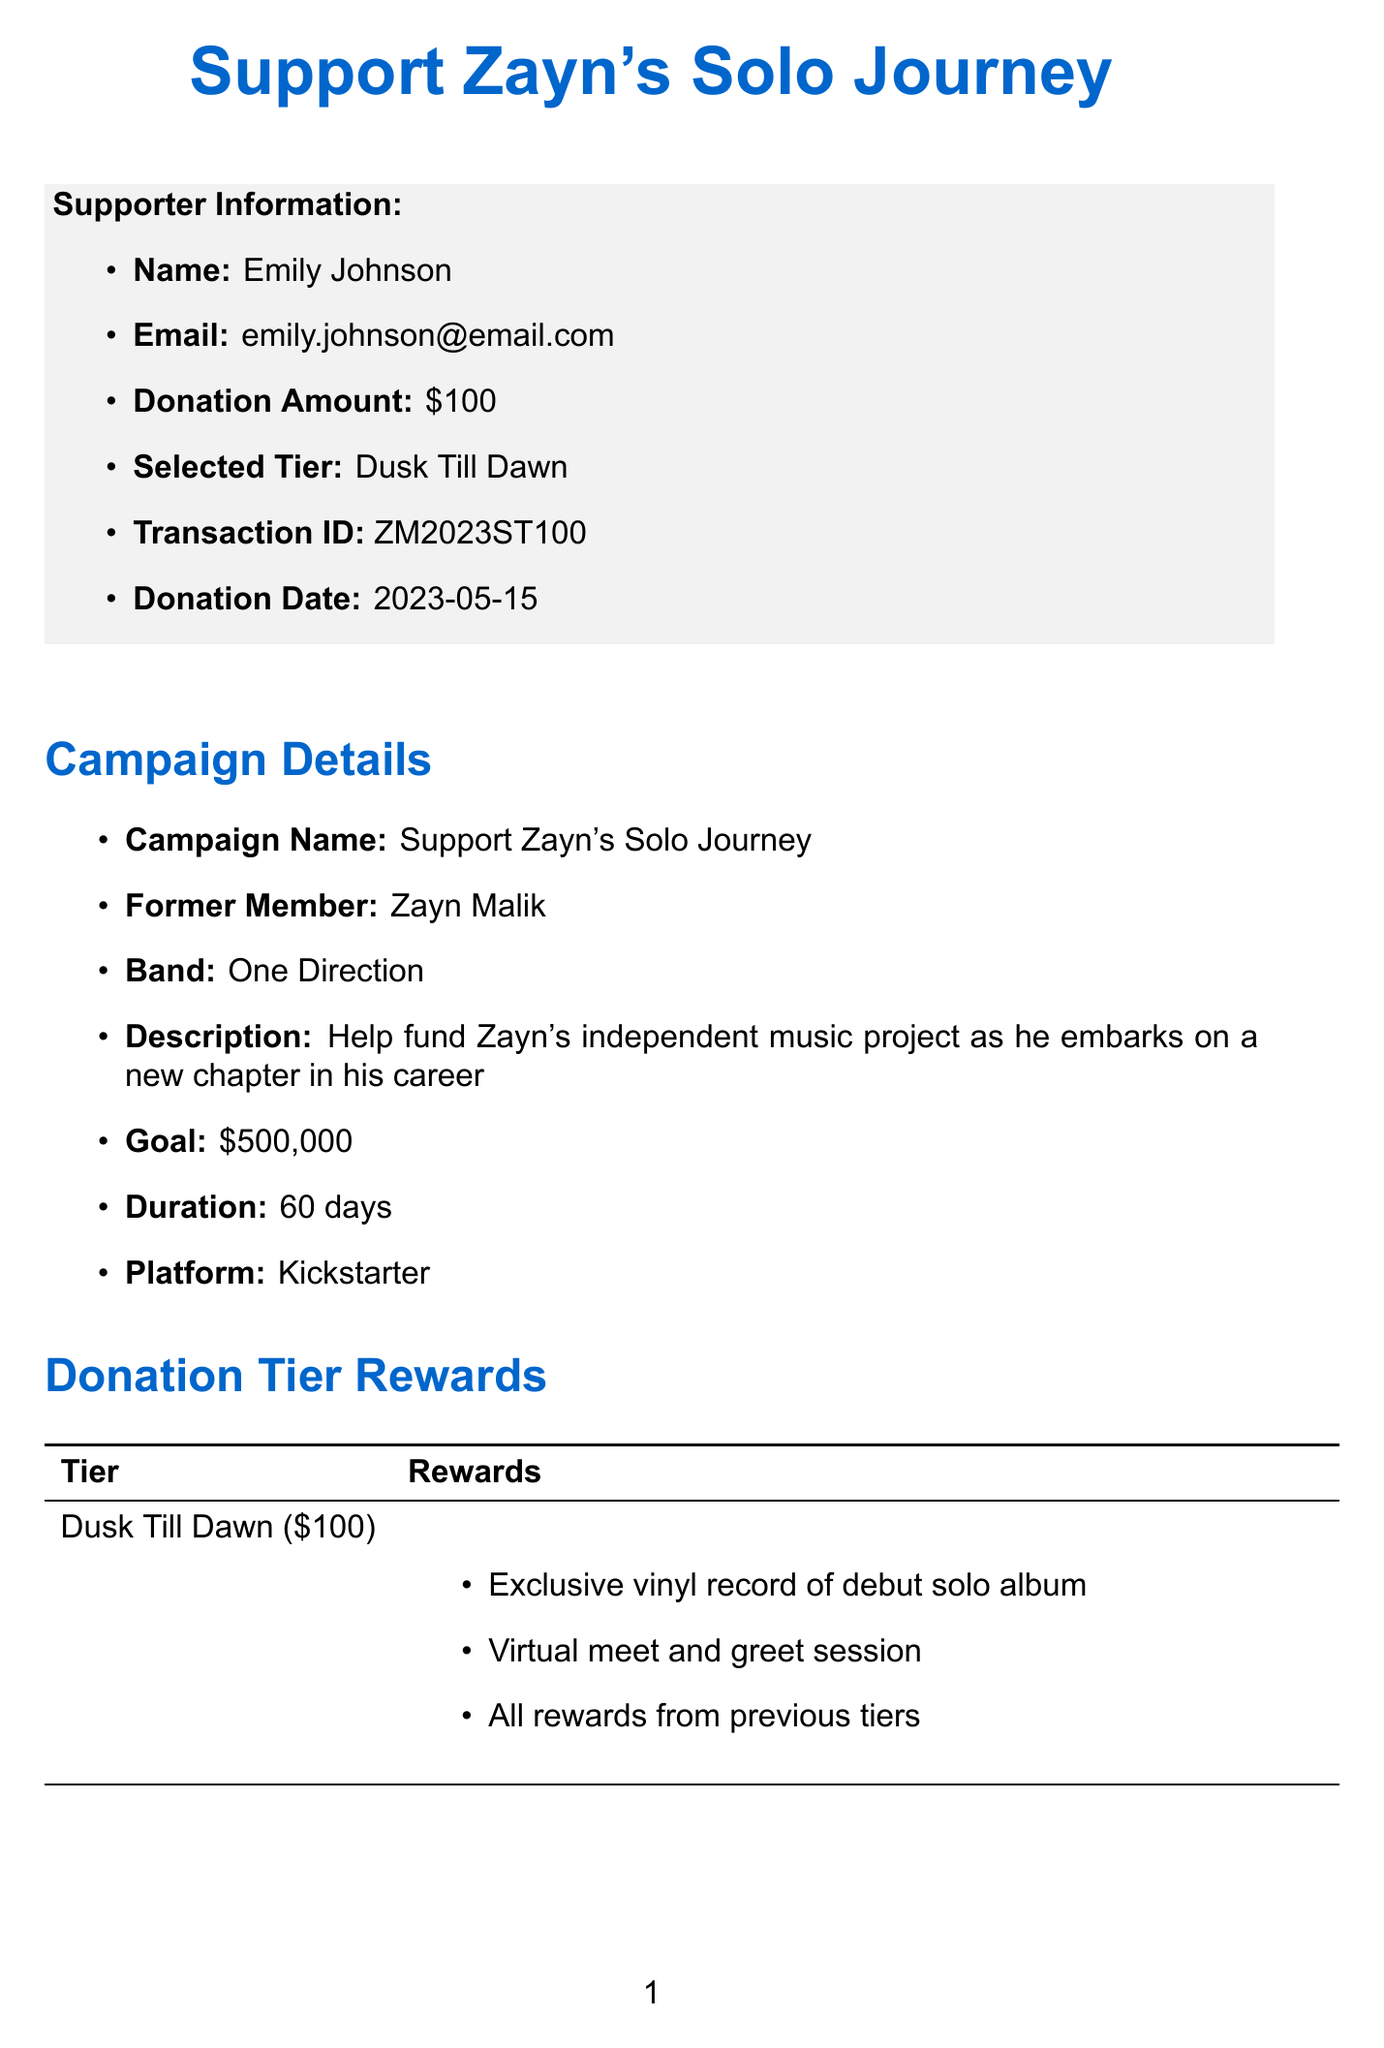what is the campaign name? The campaign name is mentioned in the document as "Support Zayn's Solo Journey."
Answer: Support Zayn's Solo Journey who is the former member? The document specifies that the former member is Zayn Malik.
Answer: Zayn Malik what is the campaign goal amount? The document states the campaign goal amount is $500,000.
Answer: $500,000 which donation tier did Emily Johnson select? The document indicates that Emily Johnson selected the "Dusk Till Dawn" tier.
Answer: Dusk Till Dawn what is the estimated delivery date for the project? The document mentions that the estimated delivery date for the project is December 2023.
Answer: December 2023 how many days is the campaign duration? The document specifies that the campaign duration is 60 days.
Answer: 60 days what reward is included in the "Icarus Falls" donation tier? The document states that a reward in the "Icarus Falls" tier includes VIP tickets to the album launch party.
Answer: VIP tickets to album launch party what platform is the crowdfunding campaign hosted on? The document states that the platform for the crowdfunding campaign is Kickstarter.
Answer: Kickstarter what is the transaction ID for Emily Johnson's donation? The transaction ID for Emily Johnson's donation is provided in the document as ZM2023ST100.
Answer: ZM2023ST100 